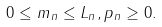<formula> <loc_0><loc_0><loc_500><loc_500>0 \leq m _ { n } \leq L _ { n } , p _ { n } \geq 0 .</formula> 